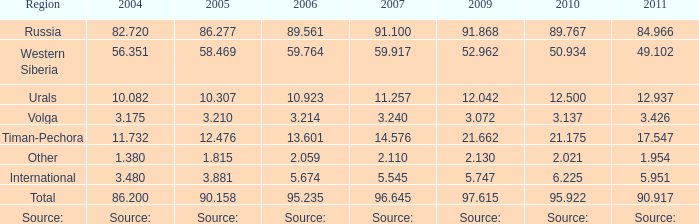If lukoil produced 90.917 million tonnes of oil in 2011, what was their production in 2004? 86.2. 